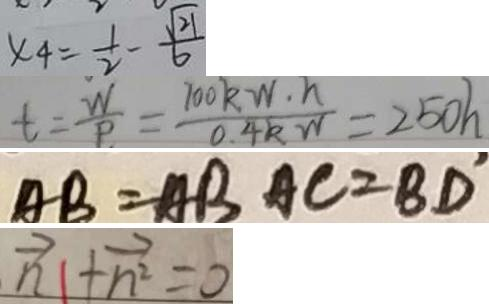<formula> <loc_0><loc_0><loc_500><loc_500>x _ { 4 } = \frac { 1 } { 2 } - \frac { \sqrt { 2 1 } } { 6 } 
 t = \frac { W } { P } = \frac { 7 0 0 k W \cdot h } { 0 . 4 k W } = 2 5 0 h 
 A B = A B A C = B D ^ { \prime } 
 \overrightarrow { n } + \overrightarrow { n ^ { 2 } } = 0</formula> 